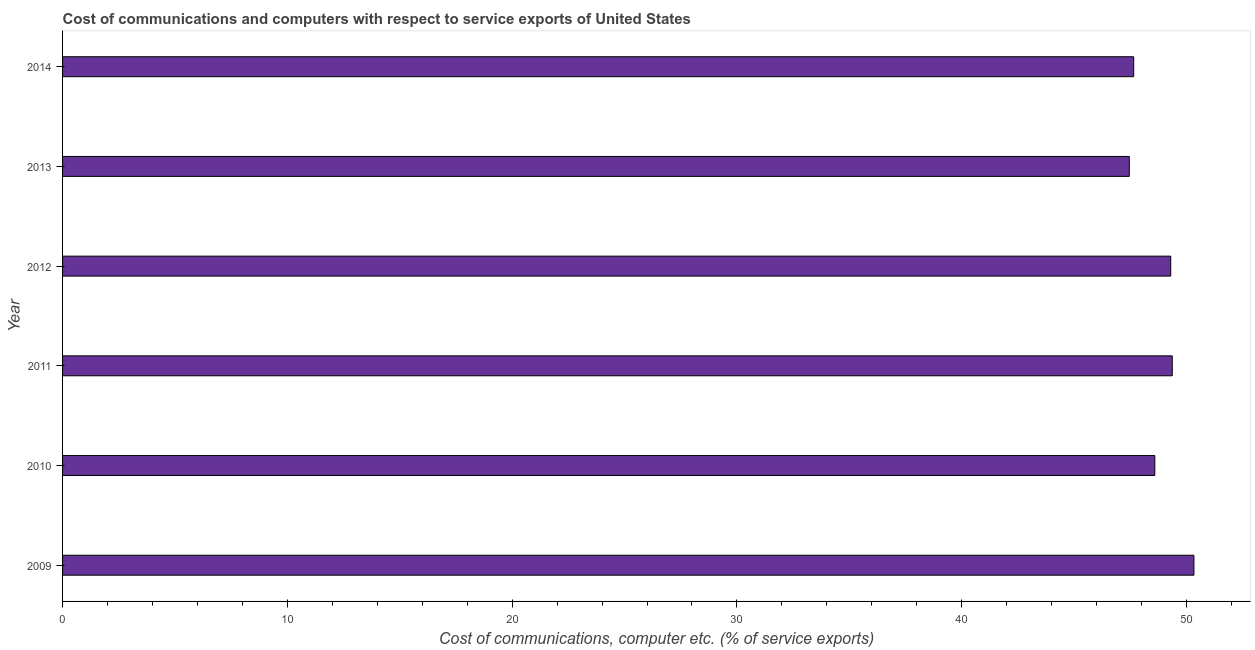Does the graph contain grids?
Give a very brief answer. No. What is the title of the graph?
Ensure brevity in your answer.  Cost of communications and computers with respect to service exports of United States. What is the label or title of the X-axis?
Keep it short and to the point. Cost of communications, computer etc. (% of service exports). What is the cost of communications and computer in 2011?
Keep it short and to the point. 49.37. Across all years, what is the maximum cost of communications and computer?
Offer a terse response. 50.33. Across all years, what is the minimum cost of communications and computer?
Your answer should be very brief. 47.45. In which year was the cost of communications and computer maximum?
Your answer should be very brief. 2009. In which year was the cost of communications and computer minimum?
Provide a short and direct response. 2013. What is the sum of the cost of communications and computer?
Offer a terse response. 292.69. What is the difference between the cost of communications and computer in 2010 and 2014?
Your response must be concise. 0.94. What is the average cost of communications and computer per year?
Provide a succinct answer. 48.78. What is the median cost of communications and computer?
Provide a short and direct response. 48.94. In how many years, is the cost of communications and computer greater than 16 %?
Offer a terse response. 6. Do a majority of the years between 2011 and 2010 (inclusive) have cost of communications and computer greater than 42 %?
Give a very brief answer. No. Is the difference between the cost of communications and computer in 2009 and 2010 greater than the difference between any two years?
Provide a succinct answer. No. What is the difference between the highest and the second highest cost of communications and computer?
Your answer should be compact. 0.96. Is the sum of the cost of communications and computer in 2010 and 2012 greater than the maximum cost of communications and computer across all years?
Your response must be concise. Yes. What is the difference between the highest and the lowest cost of communications and computer?
Ensure brevity in your answer.  2.88. In how many years, is the cost of communications and computer greater than the average cost of communications and computer taken over all years?
Your answer should be compact. 3. How many bars are there?
Provide a short and direct response. 6. How many years are there in the graph?
Offer a very short reply. 6. Are the values on the major ticks of X-axis written in scientific E-notation?
Provide a succinct answer. No. What is the Cost of communications, computer etc. (% of service exports) in 2009?
Provide a succinct answer. 50.33. What is the Cost of communications, computer etc. (% of service exports) in 2010?
Your answer should be compact. 48.59. What is the Cost of communications, computer etc. (% of service exports) of 2011?
Your response must be concise. 49.37. What is the Cost of communications, computer etc. (% of service exports) in 2012?
Provide a succinct answer. 49.3. What is the Cost of communications, computer etc. (% of service exports) in 2013?
Your response must be concise. 47.45. What is the Cost of communications, computer etc. (% of service exports) of 2014?
Offer a very short reply. 47.65. What is the difference between the Cost of communications, computer etc. (% of service exports) in 2009 and 2010?
Your answer should be compact. 1.74. What is the difference between the Cost of communications, computer etc. (% of service exports) in 2009 and 2011?
Keep it short and to the point. 0.96. What is the difference between the Cost of communications, computer etc. (% of service exports) in 2009 and 2012?
Your answer should be very brief. 1.03. What is the difference between the Cost of communications, computer etc. (% of service exports) in 2009 and 2013?
Your response must be concise. 2.88. What is the difference between the Cost of communications, computer etc. (% of service exports) in 2009 and 2014?
Give a very brief answer. 2.68. What is the difference between the Cost of communications, computer etc. (% of service exports) in 2010 and 2011?
Provide a succinct answer. -0.78. What is the difference between the Cost of communications, computer etc. (% of service exports) in 2010 and 2012?
Make the answer very short. -0.71. What is the difference between the Cost of communications, computer etc. (% of service exports) in 2010 and 2013?
Your answer should be compact. 1.14. What is the difference between the Cost of communications, computer etc. (% of service exports) in 2010 and 2014?
Provide a succinct answer. 0.94. What is the difference between the Cost of communications, computer etc. (% of service exports) in 2011 and 2012?
Make the answer very short. 0.07. What is the difference between the Cost of communications, computer etc. (% of service exports) in 2011 and 2013?
Offer a terse response. 1.91. What is the difference between the Cost of communications, computer etc. (% of service exports) in 2011 and 2014?
Make the answer very short. 1.72. What is the difference between the Cost of communications, computer etc. (% of service exports) in 2012 and 2013?
Provide a short and direct response. 1.84. What is the difference between the Cost of communications, computer etc. (% of service exports) in 2012 and 2014?
Your answer should be compact. 1.65. What is the difference between the Cost of communications, computer etc. (% of service exports) in 2013 and 2014?
Give a very brief answer. -0.2. What is the ratio of the Cost of communications, computer etc. (% of service exports) in 2009 to that in 2010?
Your response must be concise. 1.04. What is the ratio of the Cost of communications, computer etc. (% of service exports) in 2009 to that in 2013?
Keep it short and to the point. 1.06. What is the ratio of the Cost of communications, computer etc. (% of service exports) in 2009 to that in 2014?
Provide a short and direct response. 1.06. What is the ratio of the Cost of communications, computer etc. (% of service exports) in 2010 to that in 2011?
Make the answer very short. 0.98. What is the ratio of the Cost of communications, computer etc. (% of service exports) in 2010 to that in 2012?
Give a very brief answer. 0.99. What is the ratio of the Cost of communications, computer etc. (% of service exports) in 2010 to that in 2013?
Your response must be concise. 1.02. What is the ratio of the Cost of communications, computer etc. (% of service exports) in 2011 to that in 2014?
Ensure brevity in your answer.  1.04. What is the ratio of the Cost of communications, computer etc. (% of service exports) in 2012 to that in 2013?
Provide a short and direct response. 1.04. What is the ratio of the Cost of communications, computer etc. (% of service exports) in 2012 to that in 2014?
Your answer should be very brief. 1.03. 